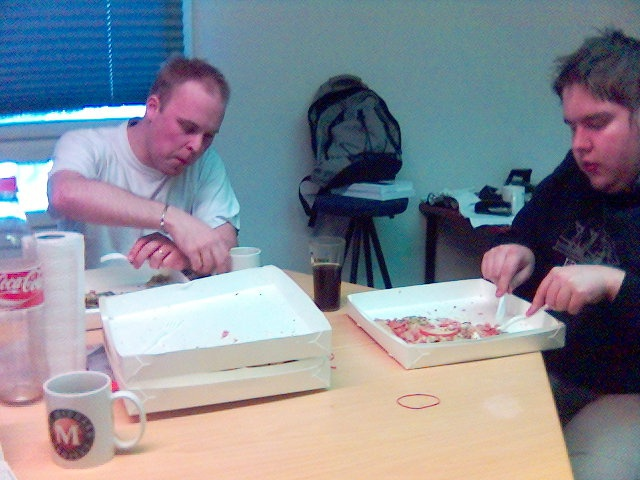Describe the objects in this image and their specific colors. I can see dining table in blue, tan, lightgray, pink, and darkgray tones, people in blue, black, gray, brown, and navy tones, people in blue, violet, lightpink, darkgray, and gray tones, backpack in blue, black, and navy tones, and bottle in blue, darkgray, lightpink, white, and violet tones in this image. 